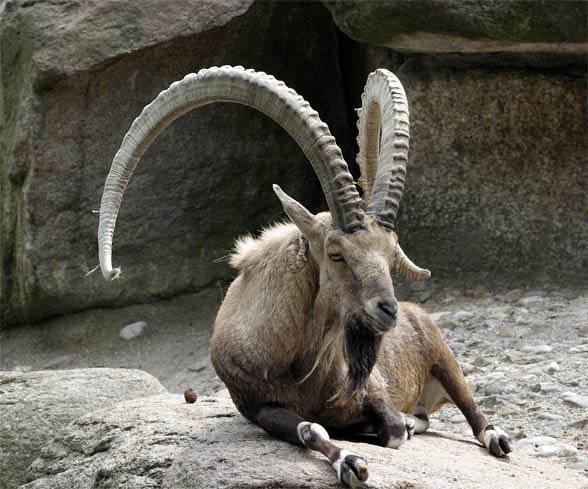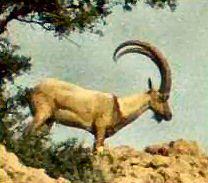The first image is the image on the left, the second image is the image on the right. For the images shown, is this caption "The left image contains one reclining long-horned goat, and the right image contains one long-horned goat standing in profile." true? Answer yes or no. Yes. The first image is the image on the left, the second image is the image on the right. For the images shown, is this caption "An ibex is laying down in the left image." true? Answer yes or no. Yes. 